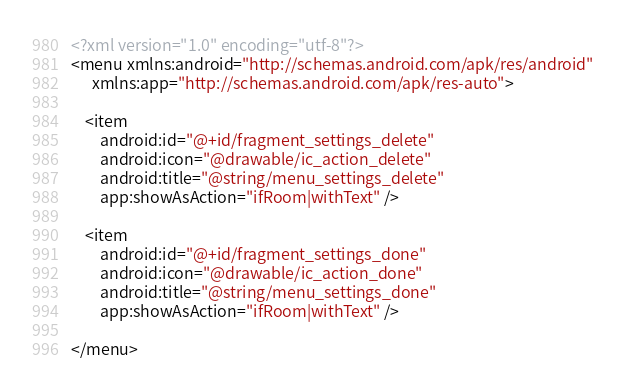Convert code to text. <code><loc_0><loc_0><loc_500><loc_500><_XML_><?xml version="1.0" encoding="utf-8"?>
<menu xmlns:android="http://schemas.android.com/apk/res/android"
      xmlns:app="http://schemas.android.com/apk/res-auto">

    <item
        android:id="@+id/fragment_settings_delete"
        android:icon="@drawable/ic_action_delete"
        android:title="@string/menu_settings_delete"
        app:showAsAction="ifRoom|withText" />

    <item
        android:id="@+id/fragment_settings_done"
        android:icon="@drawable/ic_action_done"
        android:title="@string/menu_settings_done"
        app:showAsAction="ifRoom|withText" />

</menu></code> 